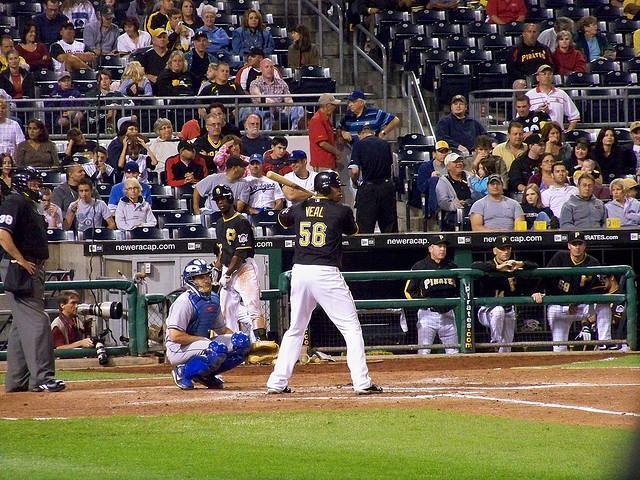What can you obtain from the website advertised?
Answer the question by selecting the correct answer among the 4 following choices.
Options: Baseball bats, sports drinks, team hat, hubcaps. Team hat. 